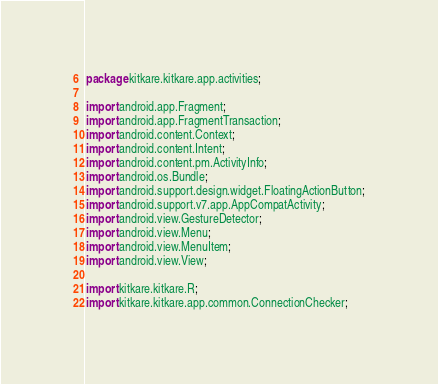<code> <loc_0><loc_0><loc_500><loc_500><_Java_>package kitkare.kitkare.app.activities;

import android.app.Fragment;
import android.app.FragmentTransaction;
import android.content.Context;
import android.content.Intent;
import android.content.pm.ActivityInfo;
import android.os.Bundle;
import android.support.design.widget.FloatingActionButton;
import android.support.v7.app.AppCompatActivity;
import android.view.GestureDetector;
import android.view.Menu;
import android.view.MenuItem;
import android.view.View;

import kitkare.kitkare.R;
import kitkare.kitkare.app.common.ConnectionChecker;</code> 